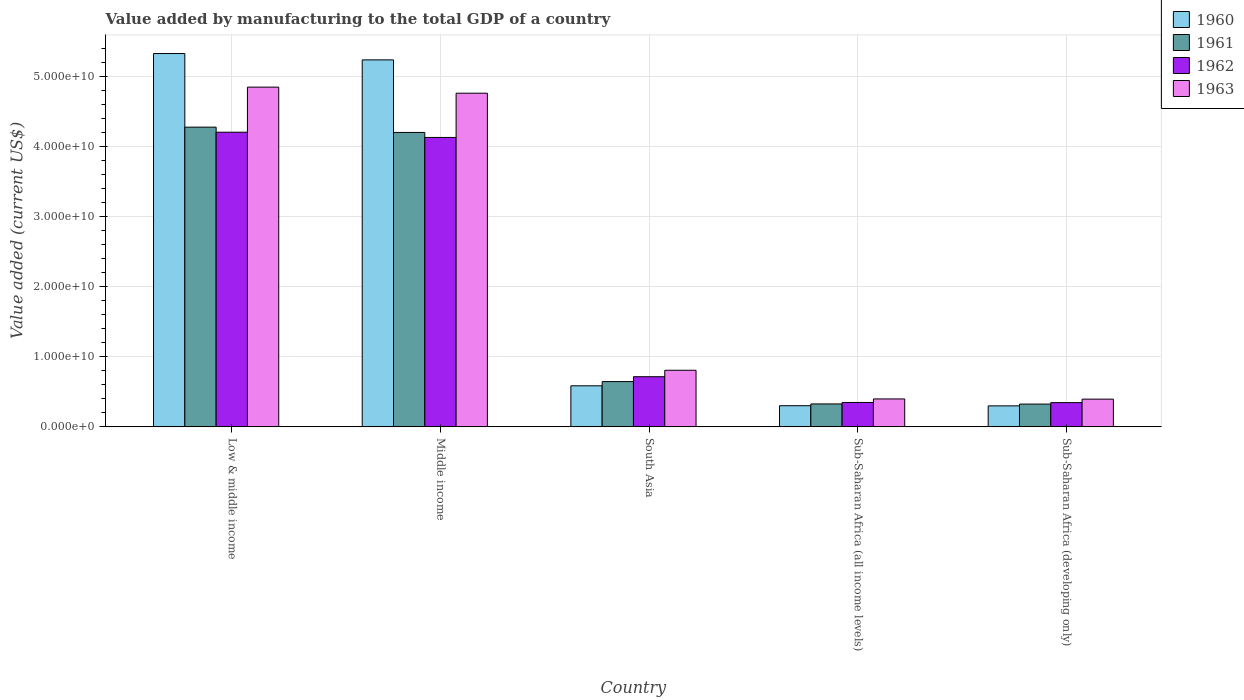How many different coloured bars are there?
Offer a very short reply. 4. How many groups of bars are there?
Ensure brevity in your answer.  5. Are the number of bars per tick equal to the number of legend labels?
Make the answer very short. Yes. How many bars are there on the 3rd tick from the left?
Your answer should be very brief. 4. How many bars are there on the 4th tick from the right?
Offer a terse response. 4. In how many cases, is the number of bars for a given country not equal to the number of legend labels?
Your answer should be compact. 0. What is the value added by manufacturing to the total GDP in 1963 in Low & middle income?
Your answer should be very brief. 4.84e+1. Across all countries, what is the maximum value added by manufacturing to the total GDP in 1961?
Provide a succinct answer. 4.27e+1. Across all countries, what is the minimum value added by manufacturing to the total GDP in 1961?
Give a very brief answer. 3.25e+09. In which country was the value added by manufacturing to the total GDP in 1963 maximum?
Your answer should be very brief. Low & middle income. In which country was the value added by manufacturing to the total GDP in 1963 minimum?
Provide a short and direct response. Sub-Saharan Africa (developing only). What is the total value added by manufacturing to the total GDP in 1960 in the graph?
Provide a short and direct response. 1.17e+11. What is the difference between the value added by manufacturing to the total GDP in 1962 in Low & middle income and that in South Asia?
Your answer should be compact. 3.49e+1. What is the difference between the value added by manufacturing to the total GDP in 1963 in South Asia and the value added by manufacturing to the total GDP in 1960 in Sub-Saharan Africa (developing only)?
Make the answer very short. 5.07e+09. What is the average value added by manufacturing to the total GDP in 1962 per country?
Give a very brief answer. 1.95e+1. What is the difference between the value added by manufacturing to the total GDP of/in 1963 and value added by manufacturing to the total GDP of/in 1962 in Low & middle income?
Provide a short and direct response. 6.43e+09. In how many countries, is the value added by manufacturing to the total GDP in 1960 greater than 22000000000 US$?
Keep it short and to the point. 2. What is the ratio of the value added by manufacturing to the total GDP in 1960 in South Asia to that in Sub-Saharan Africa (developing only)?
Provide a succinct answer. 1.96. What is the difference between the highest and the second highest value added by manufacturing to the total GDP in 1960?
Give a very brief answer. -4.74e+1. What is the difference between the highest and the lowest value added by manufacturing to the total GDP in 1963?
Provide a succinct answer. 4.45e+1. What does the 2nd bar from the left in South Asia represents?
Provide a succinct answer. 1961. What does the 2nd bar from the right in Sub-Saharan Africa (all income levels) represents?
Provide a succinct answer. 1962. Is it the case that in every country, the sum of the value added by manufacturing to the total GDP in 1961 and value added by manufacturing to the total GDP in 1963 is greater than the value added by manufacturing to the total GDP in 1960?
Offer a terse response. Yes. How many bars are there?
Provide a short and direct response. 20. Are all the bars in the graph horizontal?
Provide a short and direct response. No. What is the difference between two consecutive major ticks on the Y-axis?
Ensure brevity in your answer.  1.00e+1. Are the values on the major ticks of Y-axis written in scientific E-notation?
Your response must be concise. Yes. Does the graph contain any zero values?
Offer a terse response. No. Does the graph contain grids?
Offer a terse response. Yes. Where does the legend appear in the graph?
Make the answer very short. Top right. How are the legend labels stacked?
Keep it short and to the point. Vertical. What is the title of the graph?
Ensure brevity in your answer.  Value added by manufacturing to the total GDP of a country. What is the label or title of the Y-axis?
Your answer should be very brief. Value added (current US$). What is the Value added (current US$) in 1960 in Low & middle income?
Keep it short and to the point. 5.32e+1. What is the Value added (current US$) of 1961 in Low & middle income?
Ensure brevity in your answer.  4.27e+1. What is the Value added (current US$) of 1962 in Low & middle income?
Your answer should be compact. 4.20e+1. What is the Value added (current US$) in 1963 in Low & middle income?
Make the answer very short. 4.84e+1. What is the Value added (current US$) of 1960 in Middle income?
Give a very brief answer. 5.23e+1. What is the Value added (current US$) in 1961 in Middle income?
Make the answer very short. 4.20e+1. What is the Value added (current US$) in 1962 in Middle income?
Ensure brevity in your answer.  4.13e+1. What is the Value added (current US$) in 1963 in Middle income?
Offer a terse response. 4.76e+1. What is the Value added (current US$) of 1960 in South Asia?
Give a very brief answer. 5.86e+09. What is the Value added (current US$) in 1961 in South Asia?
Give a very brief answer. 6.45e+09. What is the Value added (current US$) of 1962 in South Asia?
Your answer should be very brief. 7.15e+09. What is the Value added (current US$) of 1963 in South Asia?
Provide a short and direct response. 8.07e+09. What is the Value added (current US$) of 1960 in Sub-Saharan Africa (all income levels)?
Offer a terse response. 3.02e+09. What is the Value added (current US$) in 1961 in Sub-Saharan Africa (all income levels)?
Provide a short and direct response. 3.27e+09. What is the Value added (current US$) in 1962 in Sub-Saharan Africa (all income levels)?
Ensure brevity in your answer.  3.48e+09. What is the Value added (current US$) in 1963 in Sub-Saharan Africa (all income levels)?
Provide a short and direct response. 3.98e+09. What is the Value added (current US$) in 1960 in Sub-Saharan Africa (developing only)?
Your response must be concise. 2.99e+09. What is the Value added (current US$) in 1961 in Sub-Saharan Africa (developing only)?
Keep it short and to the point. 3.25e+09. What is the Value added (current US$) of 1962 in Sub-Saharan Africa (developing only)?
Give a very brief answer. 3.46e+09. What is the Value added (current US$) in 1963 in Sub-Saharan Africa (developing only)?
Offer a very short reply. 3.95e+09. Across all countries, what is the maximum Value added (current US$) of 1960?
Ensure brevity in your answer.  5.32e+1. Across all countries, what is the maximum Value added (current US$) in 1961?
Provide a short and direct response. 4.27e+1. Across all countries, what is the maximum Value added (current US$) in 1962?
Provide a succinct answer. 4.20e+1. Across all countries, what is the maximum Value added (current US$) in 1963?
Your answer should be compact. 4.84e+1. Across all countries, what is the minimum Value added (current US$) of 1960?
Give a very brief answer. 2.99e+09. Across all countries, what is the minimum Value added (current US$) of 1961?
Keep it short and to the point. 3.25e+09. Across all countries, what is the minimum Value added (current US$) of 1962?
Ensure brevity in your answer.  3.46e+09. Across all countries, what is the minimum Value added (current US$) in 1963?
Keep it short and to the point. 3.95e+09. What is the total Value added (current US$) in 1960 in the graph?
Ensure brevity in your answer.  1.17e+11. What is the total Value added (current US$) of 1961 in the graph?
Make the answer very short. 9.77e+1. What is the total Value added (current US$) in 1962 in the graph?
Keep it short and to the point. 9.74e+1. What is the total Value added (current US$) of 1963 in the graph?
Your response must be concise. 1.12e+11. What is the difference between the Value added (current US$) of 1960 in Low & middle income and that in Middle income?
Your answer should be very brief. 9.04e+08. What is the difference between the Value added (current US$) in 1961 in Low & middle income and that in Middle income?
Keep it short and to the point. 7.56e+08. What is the difference between the Value added (current US$) of 1962 in Low & middle income and that in Middle income?
Offer a very short reply. 7.46e+08. What is the difference between the Value added (current US$) in 1963 in Low & middle income and that in Middle income?
Provide a succinct answer. 8.65e+08. What is the difference between the Value added (current US$) in 1960 in Low & middle income and that in South Asia?
Provide a succinct answer. 4.74e+1. What is the difference between the Value added (current US$) of 1961 in Low & middle income and that in South Asia?
Offer a very short reply. 3.63e+1. What is the difference between the Value added (current US$) in 1962 in Low & middle income and that in South Asia?
Your response must be concise. 3.49e+1. What is the difference between the Value added (current US$) in 1963 in Low & middle income and that in South Asia?
Offer a terse response. 4.04e+1. What is the difference between the Value added (current US$) of 1960 in Low & middle income and that in Sub-Saharan Africa (all income levels)?
Provide a succinct answer. 5.02e+1. What is the difference between the Value added (current US$) of 1961 in Low & middle income and that in Sub-Saharan Africa (all income levels)?
Offer a terse response. 3.95e+1. What is the difference between the Value added (current US$) in 1962 in Low & middle income and that in Sub-Saharan Africa (all income levels)?
Your answer should be compact. 3.85e+1. What is the difference between the Value added (current US$) in 1963 in Low & middle income and that in Sub-Saharan Africa (all income levels)?
Your answer should be compact. 4.44e+1. What is the difference between the Value added (current US$) in 1960 in Low & middle income and that in Sub-Saharan Africa (developing only)?
Your answer should be compact. 5.02e+1. What is the difference between the Value added (current US$) in 1961 in Low & middle income and that in Sub-Saharan Africa (developing only)?
Keep it short and to the point. 3.95e+1. What is the difference between the Value added (current US$) in 1962 in Low & middle income and that in Sub-Saharan Africa (developing only)?
Provide a short and direct response. 3.85e+1. What is the difference between the Value added (current US$) in 1963 in Low & middle income and that in Sub-Saharan Africa (developing only)?
Provide a succinct answer. 4.45e+1. What is the difference between the Value added (current US$) in 1960 in Middle income and that in South Asia?
Your answer should be very brief. 4.65e+1. What is the difference between the Value added (current US$) in 1961 in Middle income and that in South Asia?
Keep it short and to the point. 3.55e+1. What is the difference between the Value added (current US$) in 1962 in Middle income and that in South Asia?
Keep it short and to the point. 3.41e+1. What is the difference between the Value added (current US$) of 1963 in Middle income and that in South Asia?
Ensure brevity in your answer.  3.95e+1. What is the difference between the Value added (current US$) of 1960 in Middle income and that in Sub-Saharan Africa (all income levels)?
Provide a short and direct response. 4.93e+1. What is the difference between the Value added (current US$) of 1961 in Middle income and that in Sub-Saharan Africa (all income levels)?
Offer a terse response. 3.87e+1. What is the difference between the Value added (current US$) of 1962 in Middle income and that in Sub-Saharan Africa (all income levels)?
Offer a terse response. 3.78e+1. What is the difference between the Value added (current US$) of 1963 in Middle income and that in Sub-Saharan Africa (all income levels)?
Provide a short and direct response. 4.36e+1. What is the difference between the Value added (current US$) in 1960 in Middle income and that in Sub-Saharan Africa (developing only)?
Your answer should be very brief. 4.93e+1. What is the difference between the Value added (current US$) of 1961 in Middle income and that in Sub-Saharan Africa (developing only)?
Give a very brief answer. 3.87e+1. What is the difference between the Value added (current US$) of 1962 in Middle income and that in Sub-Saharan Africa (developing only)?
Offer a terse response. 3.78e+1. What is the difference between the Value added (current US$) in 1963 in Middle income and that in Sub-Saharan Africa (developing only)?
Ensure brevity in your answer.  4.36e+1. What is the difference between the Value added (current US$) of 1960 in South Asia and that in Sub-Saharan Africa (all income levels)?
Make the answer very short. 2.84e+09. What is the difference between the Value added (current US$) in 1961 in South Asia and that in Sub-Saharan Africa (all income levels)?
Make the answer very short. 3.18e+09. What is the difference between the Value added (current US$) in 1962 in South Asia and that in Sub-Saharan Africa (all income levels)?
Give a very brief answer. 3.67e+09. What is the difference between the Value added (current US$) of 1963 in South Asia and that in Sub-Saharan Africa (all income levels)?
Your answer should be compact. 4.08e+09. What is the difference between the Value added (current US$) in 1960 in South Asia and that in Sub-Saharan Africa (developing only)?
Offer a very short reply. 2.86e+09. What is the difference between the Value added (current US$) in 1961 in South Asia and that in Sub-Saharan Africa (developing only)?
Keep it short and to the point. 3.21e+09. What is the difference between the Value added (current US$) of 1962 in South Asia and that in Sub-Saharan Africa (developing only)?
Provide a succinct answer. 3.70e+09. What is the difference between the Value added (current US$) in 1963 in South Asia and that in Sub-Saharan Africa (developing only)?
Offer a very short reply. 4.11e+09. What is the difference between the Value added (current US$) of 1960 in Sub-Saharan Africa (all income levels) and that in Sub-Saharan Africa (developing only)?
Make the answer very short. 2.16e+07. What is the difference between the Value added (current US$) of 1961 in Sub-Saharan Africa (all income levels) and that in Sub-Saharan Africa (developing only)?
Your response must be concise. 2.34e+07. What is the difference between the Value added (current US$) of 1962 in Sub-Saharan Africa (all income levels) and that in Sub-Saharan Africa (developing only)?
Keep it short and to the point. 2.49e+07. What is the difference between the Value added (current US$) in 1963 in Sub-Saharan Africa (all income levels) and that in Sub-Saharan Africa (developing only)?
Your answer should be compact. 2.85e+07. What is the difference between the Value added (current US$) of 1960 in Low & middle income and the Value added (current US$) of 1961 in Middle income?
Give a very brief answer. 1.12e+1. What is the difference between the Value added (current US$) of 1960 in Low & middle income and the Value added (current US$) of 1962 in Middle income?
Offer a terse response. 1.20e+1. What is the difference between the Value added (current US$) of 1960 in Low & middle income and the Value added (current US$) of 1963 in Middle income?
Ensure brevity in your answer.  5.65e+09. What is the difference between the Value added (current US$) in 1961 in Low & middle income and the Value added (current US$) in 1962 in Middle income?
Provide a succinct answer. 1.47e+09. What is the difference between the Value added (current US$) of 1961 in Low & middle income and the Value added (current US$) of 1963 in Middle income?
Your answer should be very brief. -4.84e+09. What is the difference between the Value added (current US$) in 1962 in Low & middle income and the Value added (current US$) in 1963 in Middle income?
Keep it short and to the point. -5.56e+09. What is the difference between the Value added (current US$) of 1960 in Low & middle income and the Value added (current US$) of 1961 in South Asia?
Ensure brevity in your answer.  4.68e+1. What is the difference between the Value added (current US$) of 1960 in Low & middle income and the Value added (current US$) of 1962 in South Asia?
Your answer should be compact. 4.61e+1. What is the difference between the Value added (current US$) in 1960 in Low & middle income and the Value added (current US$) in 1963 in South Asia?
Give a very brief answer. 4.52e+1. What is the difference between the Value added (current US$) of 1961 in Low & middle income and the Value added (current US$) of 1962 in South Asia?
Provide a succinct answer. 3.56e+1. What is the difference between the Value added (current US$) of 1961 in Low & middle income and the Value added (current US$) of 1963 in South Asia?
Give a very brief answer. 3.47e+1. What is the difference between the Value added (current US$) of 1962 in Low & middle income and the Value added (current US$) of 1963 in South Asia?
Your answer should be very brief. 3.39e+1. What is the difference between the Value added (current US$) in 1960 in Low & middle income and the Value added (current US$) in 1961 in Sub-Saharan Africa (all income levels)?
Ensure brevity in your answer.  4.99e+1. What is the difference between the Value added (current US$) of 1960 in Low & middle income and the Value added (current US$) of 1962 in Sub-Saharan Africa (all income levels)?
Provide a succinct answer. 4.97e+1. What is the difference between the Value added (current US$) of 1960 in Low & middle income and the Value added (current US$) of 1963 in Sub-Saharan Africa (all income levels)?
Offer a very short reply. 4.92e+1. What is the difference between the Value added (current US$) of 1961 in Low & middle income and the Value added (current US$) of 1962 in Sub-Saharan Africa (all income levels)?
Provide a succinct answer. 3.92e+1. What is the difference between the Value added (current US$) in 1961 in Low & middle income and the Value added (current US$) in 1963 in Sub-Saharan Africa (all income levels)?
Give a very brief answer. 3.87e+1. What is the difference between the Value added (current US$) in 1962 in Low & middle income and the Value added (current US$) in 1963 in Sub-Saharan Africa (all income levels)?
Your response must be concise. 3.80e+1. What is the difference between the Value added (current US$) of 1960 in Low & middle income and the Value added (current US$) of 1961 in Sub-Saharan Africa (developing only)?
Your answer should be very brief. 5.00e+1. What is the difference between the Value added (current US$) of 1960 in Low & middle income and the Value added (current US$) of 1962 in Sub-Saharan Africa (developing only)?
Keep it short and to the point. 4.98e+1. What is the difference between the Value added (current US$) in 1960 in Low & middle income and the Value added (current US$) in 1963 in Sub-Saharan Africa (developing only)?
Provide a short and direct response. 4.93e+1. What is the difference between the Value added (current US$) of 1961 in Low & middle income and the Value added (current US$) of 1962 in Sub-Saharan Africa (developing only)?
Your response must be concise. 3.93e+1. What is the difference between the Value added (current US$) in 1961 in Low & middle income and the Value added (current US$) in 1963 in Sub-Saharan Africa (developing only)?
Give a very brief answer. 3.88e+1. What is the difference between the Value added (current US$) in 1962 in Low & middle income and the Value added (current US$) in 1963 in Sub-Saharan Africa (developing only)?
Ensure brevity in your answer.  3.80e+1. What is the difference between the Value added (current US$) of 1960 in Middle income and the Value added (current US$) of 1961 in South Asia?
Your answer should be compact. 4.59e+1. What is the difference between the Value added (current US$) of 1960 in Middle income and the Value added (current US$) of 1962 in South Asia?
Offer a very short reply. 4.52e+1. What is the difference between the Value added (current US$) of 1960 in Middle income and the Value added (current US$) of 1963 in South Asia?
Give a very brief answer. 4.42e+1. What is the difference between the Value added (current US$) of 1961 in Middle income and the Value added (current US$) of 1962 in South Asia?
Give a very brief answer. 3.48e+1. What is the difference between the Value added (current US$) in 1961 in Middle income and the Value added (current US$) in 1963 in South Asia?
Offer a terse response. 3.39e+1. What is the difference between the Value added (current US$) in 1962 in Middle income and the Value added (current US$) in 1963 in South Asia?
Ensure brevity in your answer.  3.32e+1. What is the difference between the Value added (current US$) of 1960 in Middle income and the Value added (current US$) of 1961 in Sub-Saharan Africa (all income levels)?
Keep it short and to the point. 4.90e+1. What is the difference between the Value added (current US$) in 1960 in Middle income and the Value added (current US$) in 1962 in Sub-Saharan Africa (all income levels)?
Give a very brief answer. 4.88e+1. What is the difference between the Value added (current US$) in 1960 in Middle income and the Value added (current US$) in 1963 in Sub-Saharan Africa (all income levels)?
Provide a succinct answer. 4.83e+1. What is the difference between the Value added (current US$) of 1961 in Middle income and the Value added (current US$) of 1962 in Sub-Saharan Africa (all income levels)?
Keep it short and to the point. 3.85e+1. What is the difference between the Value added (current US$) of 1961 in Middle income and the Value added (current US$) of 1963 in Sub-Saharan Africa (all income levels)?
Your response must be concise. 3.80e+1. What is the difference between the Value added (current US$) of 1962 in Middle income and the Value added (current US$) of 1963 in Sub-Saharan Africa (all income levels)?
Your answer should be compact. 3.73e+1. What is the difference between the Value added (current US$) of 1960 in Middle income and the Value added (current US$) of 1961 in Sub-Saharan Africa (developing only)?
Your answer should be very brief. 4.91e+1. What is the difference between the Value added (current US$) in 1960 in Middle income and the Value added (current US$) in 1962 in Sub-Saharan Africa (developing only)?
Make the answer very short. 4.89e+1. What is the difference between the Value added (current US$) of 1960 in Middle income and the Value added (current US$) of 1963 in Sub-Saharan Africa (developing only)?
Ensure brevity in your answer.  4.84e+1. What is the difference between the Value added (current US$) of 1961 in Middle income and the Value added (current US$) of 1962 in Sub-Saharan Africa (developing only)?
Make the answer very short. 3.85e+1. What is the difference between the Value added (current US$) in 1961 in Middle income and the Value added (current US$) in 1963 in Sub-Saharan Africa (developing only)?
Your response must be concise. 3.80e+1. What is the difference between the Value added (current US$) in 1962 in Middle income and the Value added (current US$) in 1963 in Sub-Saharan Africa (developing only)?
Ensure brevity in your answer.  3.73e+1. What is the difference between the Value added (current US$) of 1960 in South Asia and the Value added (current US$) of 1961 in Sub-Saharan Africa (all income levels)?
Your answer should be very brief. 2.58e+09. What is the difference between the Value added (current US$) in 1960 in South Asia and the Value added (current US$) in 1962 in Sub-Saharan Africa (all income levels)?
Offer a terse response. 2.37e+09. What is the difference between the Value added (current US$) in 1960 in South Asia and the Value added (current US$) in 1963 in Sub-Saharan Africa (all income levels)?
Keep it short and to the point. 1.87e+09. What is the difference between the Value added (current US$) of 1961 in South Asia and the Value added (current US$) of 1962 in Sub-Saharan Africa (all income levels)?
Make the answer very short. 2.97e+09. What is the difference between the Value added (current US$) in 1961 in South Asia and the Value added (current US$) in 1963 in Sub-Saharan Africa (all income levels)?
Your answer should be very brief. 2.47e+09. What is the difference between the Value added (current US$) of 1962 in South Asia and the Value added (current US$) of 1963 in Sub-Saharan Africa (all income levels)?
Give a very brief answer. 3.17e+09. What is the difference between the Value added (current US$) of 1960 in South Asia and the Value added (current US$) of 1961 in Sub-Saharan Africa (developing only)?
Your answer should be very brief. 2.61e+09. What is the difference between the Value added (current US$) in 1960 in South Asia and the Value added (current US$) in 1962 in Sub-Saharan Africa (developing only)?
Your answer should be very brief. 2.40e+09. What is the difference between the Value added (current US$) in 1960 in South Asia and the Value added (current US$) in 1963 in Sub-Saharan Africa (developing only)?
Ensure brevity in your answer.  1.90e+09. What is the difference between the Value added (current US$) in 1961 in South Asia and the Value added (current US$) in 1962 in Sub-Saharan Africa (developing only)?
Make the answer very short. 3.00e+09. What is the difference between the Value added (current US$) of 1961 in South Asia and the Value added (current US$) of 1963 in Sub-Saharan Africa (developing only)?
Make the answer very short. 2.50e+09. What is the difference between the Value added (current US$) of 1962 in South Asia and the Value added (current US$) of 1963 in Sub-Saharan Africa (developing only)?
Offer a very short reply. 3.20e+09. What is the difference between the Value added (current US$) in 1960 in Sub-Saharan Africa (all income levels) and the Value added (current US$) in 1961 in Sub-Saharan Africa (developing only)?
Keep it short and to the point. -2.32e+08. What is the difference between the Value added (current US$) of 1960 in Sub-Saharan Africa (all income levels) and the Value added (current US$) of 1962 in Sub-Saharan Africa (developing only)?
Your response must be concise. -4.40e+08. What is the difference between the Value added (current US$) in 1960 in Sub-Saharan Africa (all income levels) and the Value added (current US$) in 1963 in Sub-Saharan Africa (developing only)?
Your answer should be compact. -9.39e+08. What is the difference between the Value added (current US$) of 1961 in Sub-Saharan Africa (all income levels) and the Value added (current US$) of 1962 in Sub-Saharan Africa (developing only)?
Offer a terse response. -1.85e+08. What is the difference between the Value added (current US$) in 1961 in Sub-Saharan Africa (all income levels) and the Value added (current US$) in 1963 in Sub-Saharan Africa (developing only)?
Make the answer very short. -6.84e+08. What is the difference between the Value added (current US$) of 1962 in Sub-Saharan Africa (all income levels) and the Value added (current US$) of 1963 in Sub-Saharan Africa (developing only)?
Make the answer very short. -4.74e+08. What is the average Value added (current US$) in 1960 per country?
Make the answer very short. 2.35e+1. What is the average Value added (current US$) in 1961 per country?
Offer a terse response. 1.95e+1. What is the average Value added (current US$) of 1962 per country?
Ensure brevity in your answer.  1.95e+1. What is the average Value added (current US$) in 1963 per country?
Give a very brief answer. 2.24e+1. What is the difference between the Value added (current US$) of 1960 and Value added (current US$) of 1961 in Low & middle income?
Ensure brevity in your answer.  1.05e+1. What is the difference between the Value added (current US$) of 1960 and Value added (current US$) of 1962 in Low & middle income?
Offer a very short reply. 1.12e+1. What is the difference between the Value added (current US$) of 1960 and Value added (current US$) of 1963 in Low & middle income?
Offer a terse response. 4.79e+09. What is the difference between the Value added (current US$) in 1961 and Value added (current US$) in 1962 in Low & middle income?
Provide a succinct answer. 7.22e+08. What is the difference between the Value added (current US$) of 1961 and Value added (current US$) of 1963 in Low & middle income?
Your response must be concise. -5.70e+09. What is the difference between the Value added (current US$) of 1962 and Value added (current US$) of 1963 in Low & middle income?
Your answer should be compact. -6.43e+09. What is the difference between the Value added (current US$) in 1960 and Value added (current US$) in 1961 in Middle income?
Offer a very short reply. 1.03e+1. What is the difference between the Value added (current US$) of 1960 and Value added (current US$) of 1962 in Middle income?
Your response must be concise. 1.11e+1. What is the difference between the Value added (current US$) in 1960 and Value added (current US$) in 1963 in Middle income?
Make the answer very short. 4.75e+09. What is the difference between the Value added (current US$) in 1961 and Value added (current US$) in 1962 in Middle income?
Provide a succinct answer. 7.12e+08. What is the difference between the Value added (current US$) in 1961 and Value added (current US$) in 1963 in Middle income?
Provide a short and direct response. -5.59e+09. What is the difference between the Value added (current US$) in 1962 and Value added (current US$) in 1963 in Middle income?
Ensure brevity in your answer.  -6.31e+09. What is the difference between the Value added (current US$) in 1960 and Value added (current US$) in 1961 in South Asia?
Your answer should be compact. -5.98e+08. What is the difference between the Value added (current US$) of 1960 and Value added (current US$) of 1962 in South Asia?
Give a very brief answer. -1.30e+09. What is the difference between the Value added (current US$) in 1960 and Value added (current US$) in 1963 in South Asia?
Provide a succinct answer. -2.21e+09. What is the difference between the Value added (current US$) in 1961 and Value added (current US$) in 1962 in South Asia?
Keep it short and to the point. -6.98e+08. What is the difference between the Value added (current US$) of 1961 and Value added (current US$) of 1963 in South Asia?
Give a very brief answer. -1.61e+09. What is the difference between the Value added (current US$) in 1962 and Value added (current US$) in 1963 in South Asia?
Give a very brief answer. -9.17e+08. What is the difference between the Value added (current US$) of 1960 and Value added (current US$) of 1961 in Sub-Saharan Africa (all income levels)?
Give a very brief answer. -2.55e+08. What is the difference between the Value added (current US$) of 1960 and Value added (current US$) of 1962 in Sub-Saharan Africa (all income levels)?
Make the answer very short. -4.65e+08. What is the difference between the Value added (current US$) in 1960 and Value added (current US$) in 1963 in Sub-Saharan Africa (all income levels)?
Offer a terse response. -9.68e+08. What is the difference between the Value added (current US$) in 1961 and Value added (current US$) in 1962 in Sub-Saharan Africa (all income levels)?
Offer a terse response. -2.09e+08. What is the difference between the Value added (current US$) in 1961 and Value added (current US$) in 1963 in Sub-Saharan Africa (all income levels)?
Your answer should be compact. -7.12e+08. What is the difference between the Value added (current US$) in 1962 and Value added (current US$) in 1963 in Sub-Saharan Africa (all income levels)?
Ensure brevity in your answer.  -5.03e+08. What is the difference between the Value added (current US$) in 1960 and Value added (current US$) in 1961 in Sub-Saharan Africa (developing only)?
Your answer should be compact. -2.54e+08. What is the difference between the Value added (current US$) in 1960 and Value added (current US$) in 1962 in Sub-Saharan Africa (developing only)?
Offer a terse response. -4.61e+08. What is the difference between the Value added (current US$) of 1960 and Value added (current US$) of 1963 in Sub-Saharan Africa (developing only)?
Your answer should be compact. -9.61e+08. What is the difference between the Value added (current US$) in 1961 and Value added (current US$) in 1962 in Sub-Saharan Africa (developing only)?
Give a very brief answer. -2.08e+08. What is the difference between the Value added (current US$) of 1961 and Value added (current US$) of 1963 in Sub-Saharan Africa (developing only)?
Ensure brevity in your answer.  -7.07e+08. What is the difference between the Value added (current US$) in 1962 and Value added (current US$) in 1963 in Sub-Saharan Africa (developing only)?
Keep it short and to the point. -4.99e+08. What is the ratio of the Value added (current US$) in 1960 in Low & middle income to that in Middle income?
Offer a terse response. 1.02. What is the ratio of the Value added (current US$) of 1961 in Low & middle income to that in Middle income?
Ensure brevity in your answer.  1.02. What is the ratio of the Value added (current US$) of 1962 in Low & middle income to that in Middle income?
Make the answer very short. 1.02. What is the ratio of the Value added (current US$) of 1963 in Low & middle income to that in Middle income?
Your answer should be very brief. 1.02. What is the ratio of the Value added (current US$) of 1960 in Low & middle income to that in South Asia?
Offer a very short reply. 9.09. What is the ratio of the Value added (current US$) of 1961 in Low & middle income to that in South Asia?
Keep it short and to the point. 6.62. What is the ratio of the Value added (current US$) in 1962 in Low & middle income to that in South Asia?
Provide a short and direct response. 5.87. What is the ratio of the Value added (current US$) in 1963 in Low & middle income to that in South Asia?
Give a very brief answer. 6. What is the ratio of the Value added (current US$) in 1960 in Low & middle income to that in Sub-Saharan Africa (all income levels)?
Your answer should be compact. 17.65. What is the ratio of the Value added (current US$) in 1961 in Low & middle income to that in Sub-Saharan Africa (all income levels)?
Your answer should be compact. 13.06. What is the ratio of the Value added (current US$) in 1962 in Low & middle income to that in Sub-Saharan Africa (all income levels)?
Provide a short and direct response. 12.07. What is the ratio of the Value added (current US$) of 1963 in Low & middle income to that in Sub-Saharan Africa (all income levels)?
Provide a short and direct response. 12.16. What is the ratio of the Value added (current US$) of 1960 in Low & middle income to that in Sub-Saharan Africa (developing only)?
Provide a succinct answer. 17.77. What is the ratio of the Value added (current US$) of 1961 in Low & middle income to that in Sub-Saharan Africa (developing only)?
Your answer should be compact. 13.16. What is the ratio of the Value added (current US$) of 1962 in Low & middle income to that in Sub-Saharan Africa (developing only)?
Provide a succinct answer. 12.16. What is the ratio of the Value added (current US$) in 1963 in Low & middle income to that in Sub-Saharan Africa (developing only)?
Your response must be concise. 12.25. What is the ratio of the Value added (current US$) of 1960 in Middle income to that in South Asia?
Your answer should be very brief. 8.93. What is the ratio of the Value added (current US$) of 1961 in Middle income to that in South Asia?
Provide a succinct answer. 6.5. What is the ratio of the Value added (current US$) in 1962 in Middle income to that in South Asia?
Your answer should be compact. 5.77. What is the ratio of the Value added (current US$) in 1963 in Middle income to that in South Asia?
Offer a very short reply. 5.9. What is the ratio of the Value added (current US$) of 1960 in Middle income to that in Sub-Saharan Africa (all income levels)?
Offer a terse response. 17.35. What is the ratio of the Value added (current US$) in 1961 in Middle income to that in Sub-Saharan Africa (all income levels)?
Your response must be concise. 12.83. What is the ratio of the Value added (current US$) in 1962 in Middle income to that in Sub-Saharan Africa (all income levels)?
Give a very brief answer. 11.85. What is the ratio of the Value added (current US$) of 1963 in Middle income to that in Sub-Saharan Africa (all income levels)?
Keep it short and to the point. 11.94. What is the ratio of the Value added (current US$) in 1960 in Middle income to that in Sub-Saharan Africa (developing only)?
Make the answer very short. 17.47. What is the ratio of the Value added (current US$) in 1961 in Middle income to that in Sub-Saharan Africa (developing only)?
Offer a very short reply. 12.92. What is the ratio of the Value added (current US$) of 1962 in Middle income to that in Sub-Saharan Africa (developing only)?
Offer a very short reply. 11.94. What is the ratio of the Value added (current US$) of 1963 in Middle income to that in Sub-Saharan Africa (developing only)?
Your answer should be very brief. 12.03. What is the ratio of the Value added (current US$) in 1960 in South Asia to that in Sub-Saharan Africa (all income levels)?
Provide a succinct answer. 1.94. What is the ratio of the Value added (current US$) of 1961 in South Asia to that in Sub-Saharan Africa (all income levels)?
Ensure brevity in your answer.  1.97. What is the ratio of the Value added (current US$) of 1962 in South Asia to that in Sub-Saharan Africa (all income levels)?
Ensure brevity in your answer.  2.05. What is the ratio of the Value added (current US$) in 1963 in South Asia to that in Sub-Saharan Africa (all income levels)?
Offer a very short reply. 2.03. What is the ratio of the Value added (current US$) in 1960 in South Asia to that in Sub-Saharan Africa (developing only)?
Your response must be concise. 1.96. What is the ratio of the Value added (current US$) of 1961 in South Asia to that in Sub-Saharan Africa (developing only)?
Your answer should be compact. 1.99. What is the ratio of the Value added (current US$) of 1962 in South Asia to that in Sub-Saharan Africa (developing only)?
Make the answer very short. 2.07. What is the ratio of the Value added (current US$) of 1963 in South Asia to that in Sub-Saharan Africa (developing only)?
Give a very brief answer. 2.04. What is the ratio of the Value added (current US$) of 1962 in Sub-Saharan Africa (all income levels) to that in Sub-Saharan Africa (developing only)?
Provide a short and direct response. 1.01. What is the ratio of the Value added (current US$) of 1963 in Sub-Saharan Africa (all income levels) to that in Sub-Saharan Africa (developing only)?
Offer a terse response. 1.01. What is the difference between the highest and the second highest Value added (current US$) in 1960?
Ensure brevity in your answer.  9.04e+08. What is the difference between the highest and the second highest Value added (current US$) in 1961?
Provide a succinct answer. 7.56e+08. What is the difference between the highest and the second highest Value added (current US$) of 1962?
Make the answer very short. 7.46e+08. What is the difference between the highest and the second highest Value added (current US$) of 1963?
Ensure brevity in your answer.  8.65e+08. What is the difference between the highest and the lowest Value added (current US$) in 1960?
Offer a terse response. 5.02e+1. What is the difference between the highest and the lowest Value added (current US$) in 1961?
Offer a very short reply. 3.95e+1. What is the difference between the highest and the lowest Value added (current US$) of 1962?
Provide a short and direct response. 3.85e+1. What is the difference between the highest and the lowest Value added (current US$) in 1963?
Your answer should be very brief. 4.45e+1. 